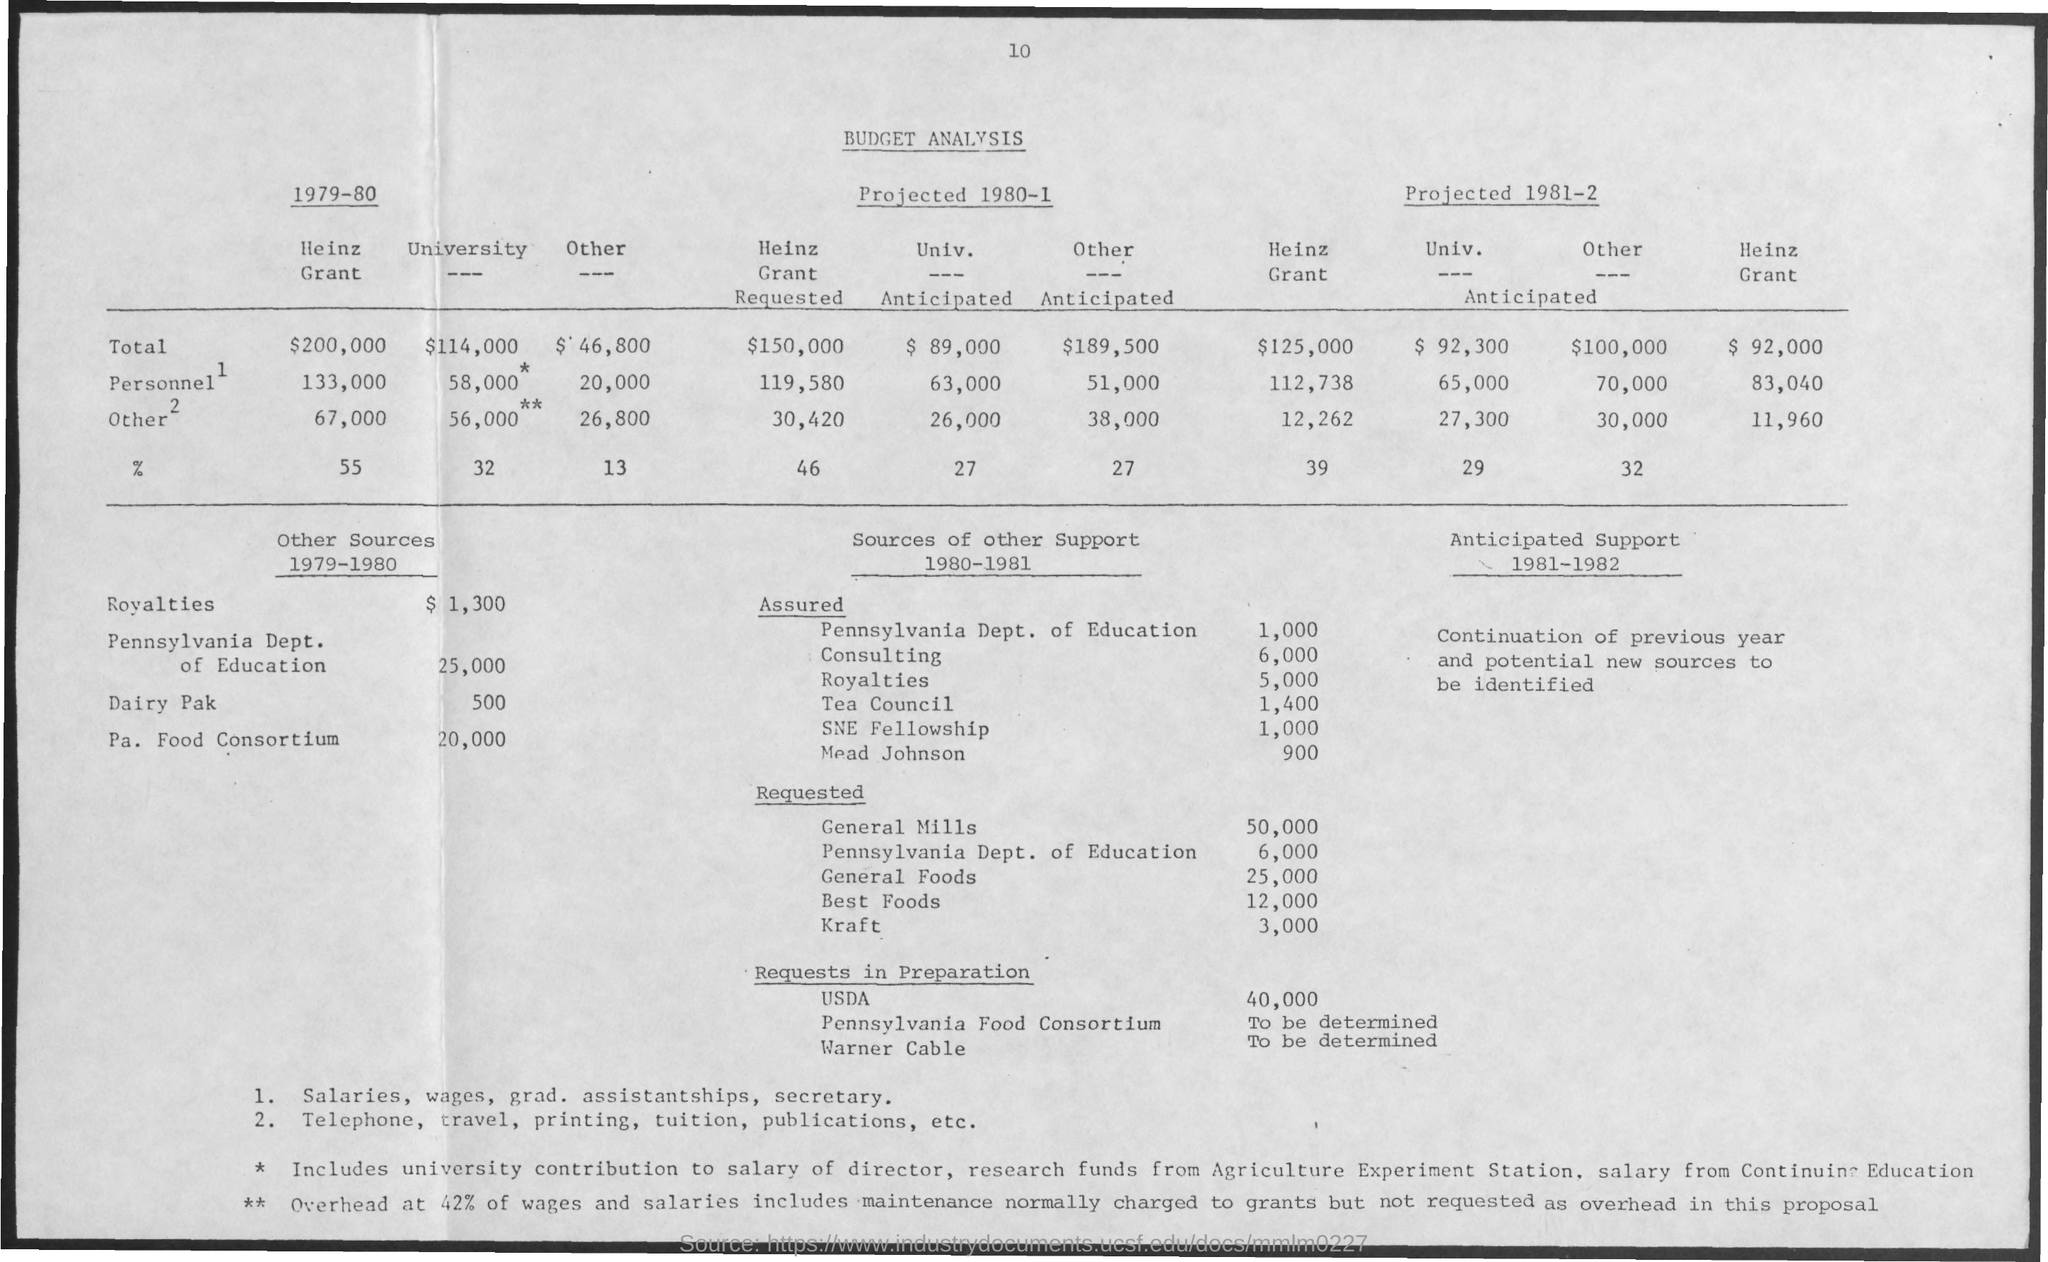What is the Page Number?
Keep it short and to the point. 10. What is the title of the document?
Keep it short and to the point. Budget Analysis. 